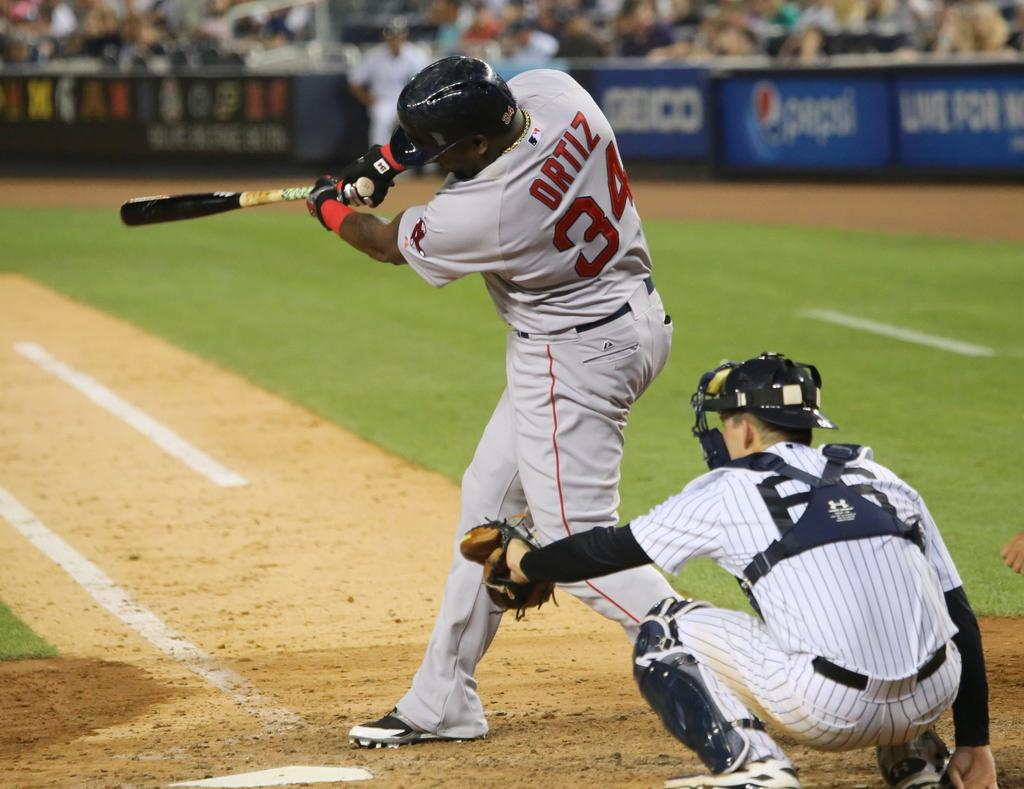What sport are the players in the image participating in? The players in the image are participating in cricket. What objects are the cricket players holding? The cricket players are holding objects, likely cricket bats or balls. What type of terrain is visible in the background of the image? The background of the image includes both grass and sand. What religious ceremony is taking place in the image? There is no religious ceremony present in the image; it features cricket players. Can you identify any beetles in the image? There are no beetles visible in the image. 